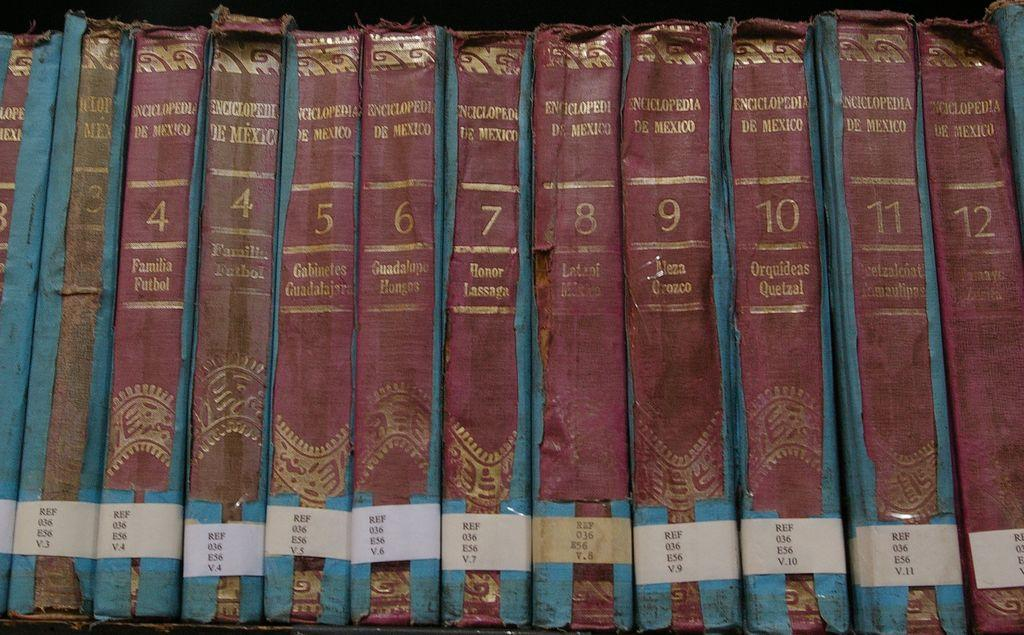<image>
Describe the image concisely. A collection of books includes 2 copies of Volume 4: Familia Futbol. 